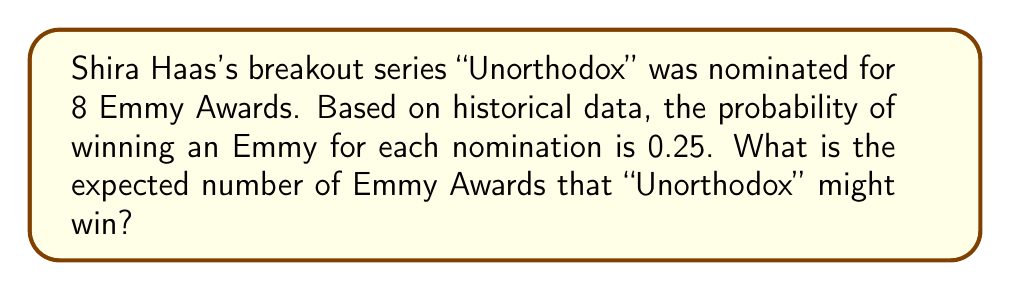Help me with this question. Let's approach this step-by-step:

1) We can model this situation using a binomial distribution, where each nomination has two possible outcomes: win or lose.

2) Let X be the random variable representing the number of Emmy Awards won.

3) We know:
   - Number of trials (nominations): n = 8
   - Probability of success (winning) for each trial: p = 0.25

4) For a binomial distribution, the expected value is given by:

   $$E(X) = np$$

5) Substituting our values:

   $$E(X) = 8 * 0.25 = 2$$

This means that, on average, we would expect "Unorthodox" to win 2 Emmy Awards given these probabilities.

Note: The actual number of awards won could be different from this expected value. The expected value gives us the long-term average if this scenario were repeated many times.
Answer: 2 Emmy Awards 